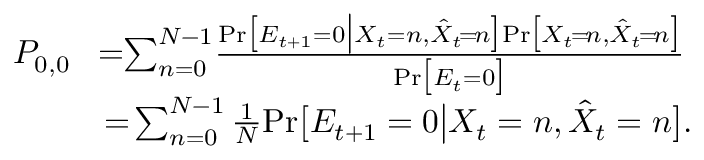<formula> <loc_0><loc_0><loc_500><loc_500>\begin{array} { r l } { P _ { 0 , 0 } } & { \, = \, \sum _ { n = 0 } ^ { N - 1 } \, \frac { P r \left [ E _ { t + 1 } = 0 \left | X _ { t } = n , \hat { X } _ { t } \, = \, n \right ] P r \left [ X _ { t } \, = \, n , \hat { X } _ { t } \, = \, n \right ] } { P r \left [ E _ { t } = 0 \right ] } } \\ & { = \, \sum _ { n = 0 } ^ { N - 1 } \frac { 1 } { N } P r \left [ E _ { t + 1 } = 0 \right | X _ { t } = n , \hat { X } _ { t } = n \right ] . } \end{array}</formula> 